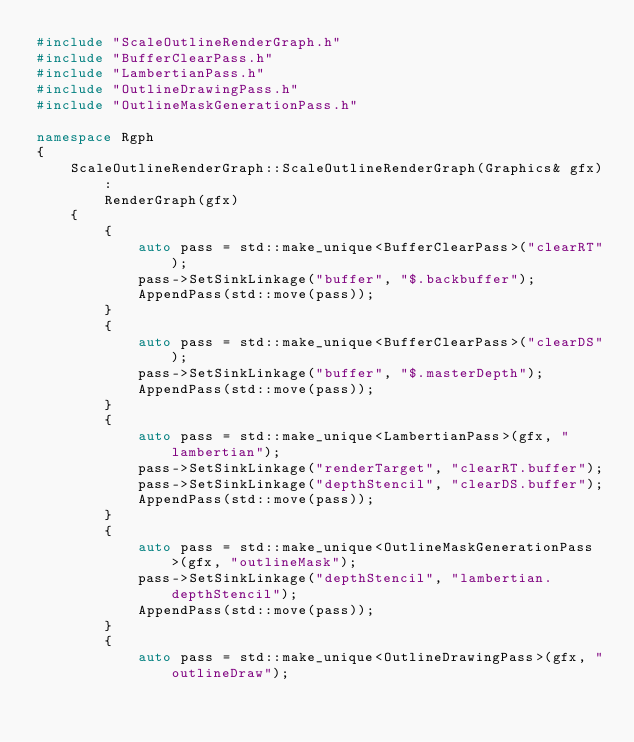<code> <loc_0><loc_0><loc_500><loc_500><_C++_>#include "ScaleOutlineRenderGraph.h"
#include "BufferClearPass.h"
#include "LambertianPass.h"
#include "OutlineDrawingPass.h"
#include "OutlineMaskGenerationPass.h"

namespace Rgph
{
	ScaleOutlineRenderGraph::ScaleOutlineRenderGraph(Graphics& gfx)
		:
		RenderGraph(gfx)
	{
		{
			auto pass = std::make_unique<BufferClearPass>("clearRT");
			pass->SetSinkLinkage("buffer", "$.backbuffer");
			AppendPass(std::move(pass));
		}
		{
			auto pass = std::make_unique<BufferClearPass>("clearDS");
			pass->SetSinkLinkage("buffer", "$.masterDepth");
			AppendPass(std::move(pass));
		}
		{
			auto pass = std::make_unique<LambertianPass>(gfx, "lambertian");
			pass->SetSinkLinkage("renderTarget", "clearRT.buffer");
			pass->SetSinkLinkage("depthStencil", "clearDS.buffer");
			AppendPass(std::move(pass));
		}
		{
			auto pass = std::make_unique<OutlineMaskGenerationPass>(gfx, "outlineMask");
			pass->SetSinkLinkage("depthStencil", "lambertian.depthStencil");
			AppendPass(std::move(pass));
		}
		{
			auto pass = std::make_unique<OutlineDrawingPass>(gfx, "outlineDraw");</code> 